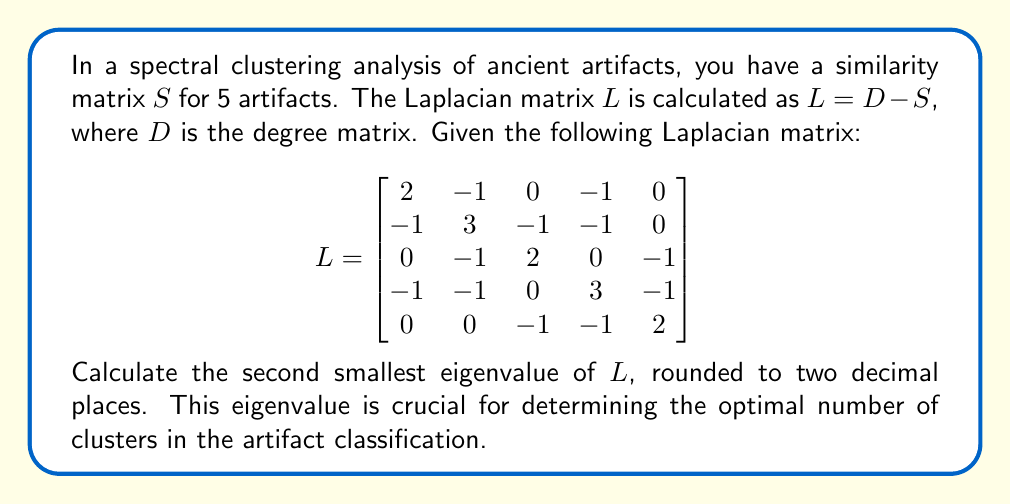Teach me how to tackle this problem. To find the second smallest eigenvalue of the Laplacian matrix $L$, we need to follow these steps:

1) First, we need to calculate the characteristic polynomial of $L$:
   $det(L - \lambda I) = 0$

2) Expand the determinant:
   $\begin{vmatrix}
   2-\lambda & -1 & 0 & -1 & 0 \\
   -1 & 3-\lambda & -1 & -1 & 0 \\
   0 & -1 & 2-\lambda & 0 & -1 \\
   -1 & -1 & 0 & 3-\lambda & -1 \\
   0 & 0 & -1 & -1 & 2-\lambda
   \end{vmatrix} = 0$

3) Solving this determinant leads to the characteristic equation:
   $\lambda^5 - 12\lambda^4 + 46\lambda^3 - 70\lambda^2 + 41\lambda = 0$

4) Factor out $\lambda$:
   $\lambda(\lambda^4 - 12\lambda^3 + 46\lambda^2 - 70\lambda + 41) = 0$

5) We can see that $\lambda = 0$ is one solution (the smallest eigenvalue of a Laplacian matrix is always 0).

6) For the remaining fourth-degree polynomial, we can use numerical methods or a computer algebra system to find the roots. The roots (eigenvalues) are approximately:
   $\lambda_1 = 0$
   $\lambda_2 \approx 0.6375$
   $\lambda_3 \approx 2.0000$
   $\lambda_4 \approx 3.8454$
   $\lambda_5 \approx 5.5171$

7) The second smallest eigenvalue is $\lambda_2 \approx 0.6375$

8) Rounding to two decimal places: $0.64$

This eigenvalue, known as the algebraic connectivity or Fiedler value, provides information about the connectivity of the graph and is crucial in spectral clustering for determining the optimal number of clusters.
Answer: $0.64$ 